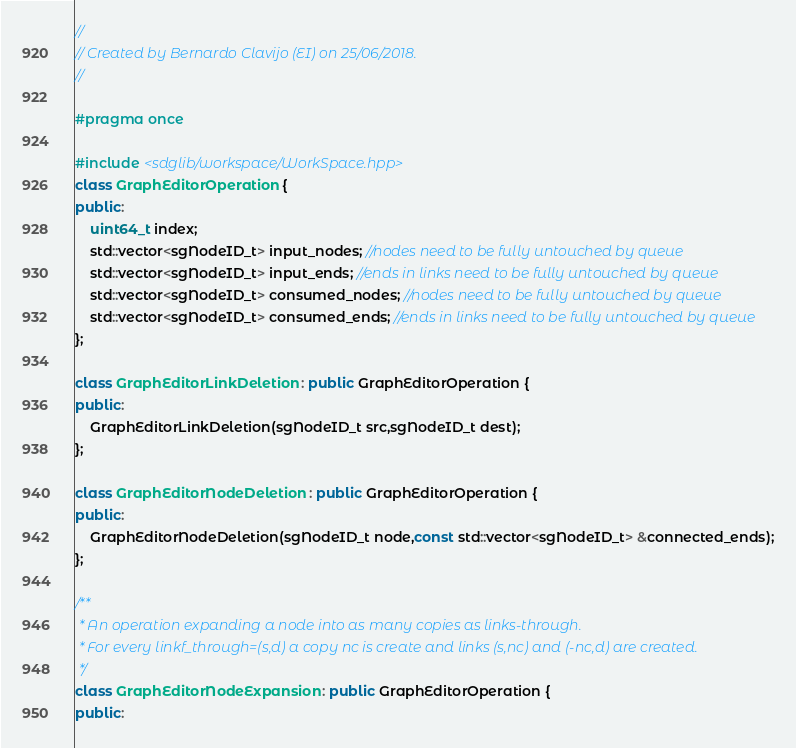<code> <loc_0><loc_0><loc_500><loc_500><_C++_>//
// Created by Bernardo Clavijo (EI) on 25/06/2018.
//

#pragma once

#include <sdglib/workspace/WorkSpace.hpp>
class GraphEditorOperation {
public:
    uint64_t index;
    std::vector<sgNodeID_t> input_nodes; //nodes need to be fully untouched by queue
    std::vector<sgNodeID_t> input_ends; //ends in links need to be fully untouched by queue
    std::vector<sgNodeID_t> consumed_nodes; //nodes need to be fully untouched by queue
    std::vector<sgNodeID_t> consumed_ends; //ends in links need to be fully untouched by queue
};

class GraphEditorLinkDeletion : public GraphEditorOperation {
public:
    GraphEditorLinkDeletion(sgNodeID_t src,sgNodeID_t dest);
};

class GraphEditorNodeDeletion : public GraphEditorOperation {
public:
    GraphEditorNodeDeletion(sgNodeID_t node,const std::vector<sgNodeID_t> &connected_ends);
};

/**
 * An operation expanding a node into as many copies as links-through.
 * For every linkf_through=(s,d) a copy nc is create and links (s,nc) and (-nc,d) are created.
 */
class GraphEditorNodeExpansion : public GraphEditorOperation {
public:</code> 